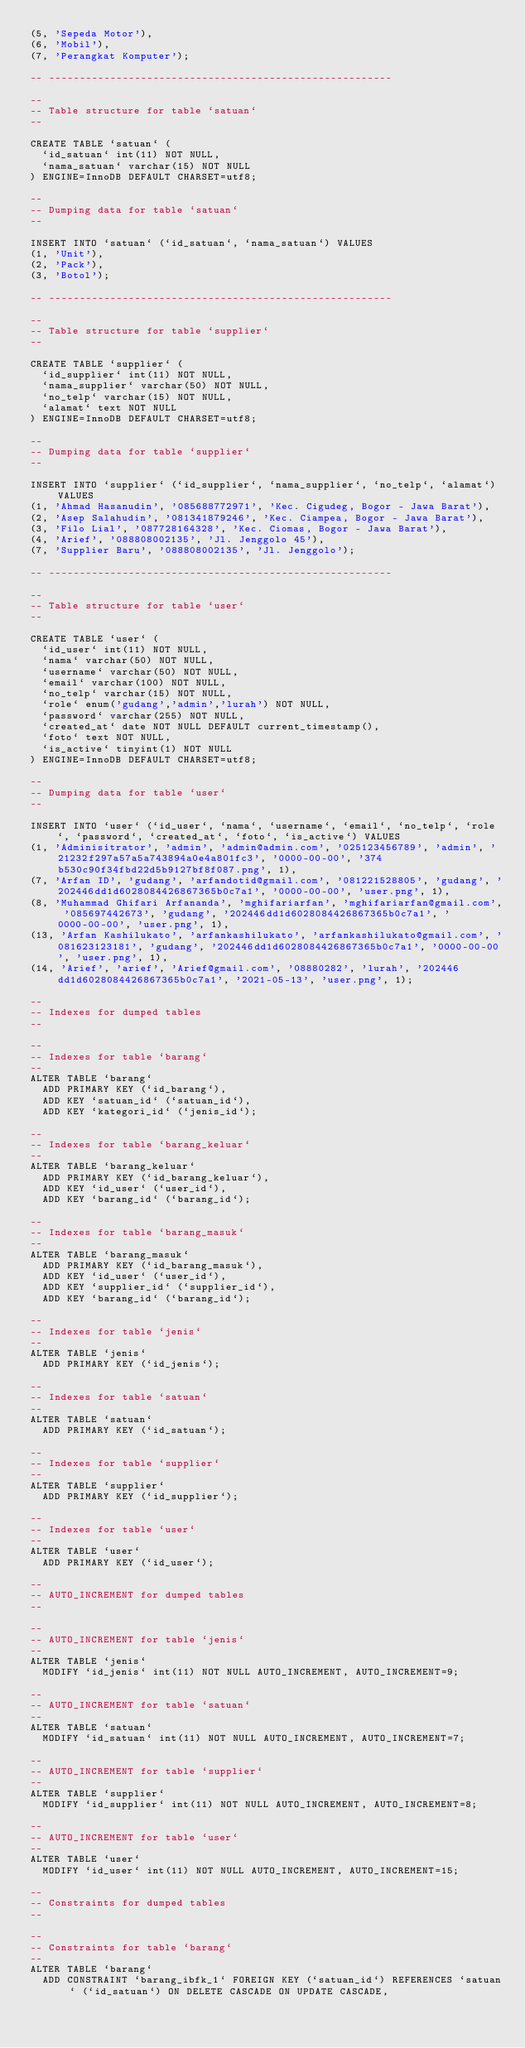Convert code to text. <code><loc_0><loc_0><loc_500><loc_500><_SQL_>(5, 'Sepeda Motor'),
(6, 'Mobil'),
(7, 'Perangkat Komputer');

-- --------------------------------------------------------

--
-- Table structure for table `satuan`
--

CREATE TABLE `satuan` (
  `id_satuan` int(11) NOT NULL,
  `nama_satuan` varchar(15) NOT NULL
) ENGINE=InnoDB DEFAULT CHARSET=utf8;

--
-- Dumping data for table `satuan`
--

INSERT INTO `satuan` (`id_satuan`, `nama_satuan`) VALUES
(1, 'Unit'),
(2, 'Pack'),
(3, 'Botol');

-- --------------------------------------------------------

--
-- Table structure for table `supplier`
--

CREATE TABLE `supplier` (
  `id_supplier` int(11) NOT NULL,
  `nama_supplier` varchar(50) NOT NULL,
  `no_telp` varchar(15) NOT NULL,
  `alamat` text NOT NULL
) ENGINE=InnoDB DEFAULT CHARSET=utf8;

--
-- Dumping data for table `supplier`
--

INSERT INTO `supplier` (`id_supplier`, `nama_supplier`, `no_telp`, `alamat`) VALUES
(1, 'Ahmad Hasanudin', '085688772971', 'Kec. Cigudeg, Bogor - Jawa Barat'),
(2, 'Asep Salahudin', '081341879246', 'Kec. Ciampea, Bogor - Jawa Barat'),
(3, 'Filo Lial', '087728164328', 'Kec. Ciomas, Bogor - Jawa Barat'),
(4, 'Arief', '088808002135', 'Jl. Jenggolo 45'),
(7, 'Supplier Baru', '088808002135', 'Jl. Jenggolo');

-- --------------------------------------------------------

--
-- Table structure for table `user`
--

CREATE TABLE `user` (
  `id_user` int(11) NOT NULL,
  `nama` varchar(50) NOT NULL,
  `username` varchar(50) NOT NULL,
  `email` varchar(100) NOT NULL,
  `no_telp` varchar(15) NOT NULL,
  `role` enum('gudang','admin','lurah') NOT NULL,
  `password` varchar(255) NOT NULL,
  `created_at` date NOT NULL DEFAULT current_timestamp(),
  `foto` text NOT NULL,
  `is_active` tinyint(1) NOT NULL
) ENGINE=InnoDB DEFAULT CHARSET=utf8;

--
-- Dumping data for table `user`
--

INSERT INTO `user` (`id_user`, `nama`, `username`, `email`, `no_telp`, `role`, `password`, `created_at`, `foto`, `is_active`) VALUES
(1, 'Adminisitrator', 'admin', 'admin@admin.com', '025123456789', 'admin', '21232f297a57a5a743894a0e4a801fc3', '0000-00-00', '374b530c90f34fbd22d5b9127bf8f087.png', 1),
(7, 'Arfan ID', 'gudang', 'arfandotid@gmail.com', '081221528805', 'gudang', '202446dd1d6028084426867365b0c7a1', '0000-00-00', 'user.png', 1),
(8, 'Muhammad Ghifari Arfananda', 'mghifariarfan', 'mghifariarfan@gmail.com', '085697442673', 'gudang', '202446dd1d6028084426867365b0c7a1', '0000-00-00', 'user.png', 1),
(13, 'Arfan Kashilukato', 'arfankashilukato', 'arfankashilukato@gmail.com', '081623123181', 'gudang', '202446dd1d6028084426867365b0c7a1', '0000-00-00', 'user.png', 1),
(14, 'Arief', 'arief', 'Arief@gmail.com', '08880282', 'lurah', '202446dd1d6028084426867365b0c7a1', '2021-05-13', 'user.png', 1);

--
-- Indexes for dumped tables
--

--
-- Indexes for table `barang`
--
ALTER TABLE `barang`
  ADD PRIMARY KEY (`id_barang`),
  ADD KEY `satuan_id` (`satuan_id`),
  ADD KEY `kategori_id` (`jenis_id`);

--
-- Indexes for table `barang_keluar`
--
ALTER TABLE `barang_keluar`
  ADD PRIMARY KEY (`id_barang_keluar`),
  ADD KEY `id_user` (`user_id`),
  ADD KEY `barang_id` (`barang_id`);

--
-- Indexes for table `barang_masuk`
--
ALTER TABLE `barang_masuk`
  ADD PRIMARY KEY (`id_barang_masuk`),
  ADD KEY `id_user` (`user_id`),
  ADD KEY `supplier_id` (`supplier_id`),
  ADD KEY `barang_id` (`barang_id`);

--
-- Indexes for table `jenis`
--
ALTER TABLE `jenis`
  ADD PRIMARY KEY (`id_jenis`);

--
-- Indexes for table `satuan`
--
ALTER TABLE `satuan`
  ADD PRIMARY KEY (`id_satuan`);

--
-- Indexes for table `supplier`
--
ALTER TABLE `supplier`
  ADD PRIMARY KEY (`id_supplier`);

--
-- Indexes for table `user`
--
ALTER TABLE `user`
  ADD PRIMARY KEY (`id_user`);

--
-- AUTO_INCREMENT for dumped tables
--

--
-- AUTO_INCREMENT for table `jenis`
--
ALTER TABLE `jenis`
  MODIFY `id_jenis` int(11) NOT NULL AUTO_INCREMENT, AUTO_INCREMENT=9;

--
-- AUTO_INCREMENT for table `satuan`
--
ALTER TABLE `satuan`
  MODIFY `id_satuan` int(11) NOT NULL AUTO_INCREMENT, AUTO_INCREMENT=7;

--
-- AUTO_INCREMENT for table `supplier`
--
ALTER TABLE `supplier`
  MODIFY `id_supplier` int(11) NOT NULL AUTO_INCREMENT, AUTO_INCREMENT=8;

--
-- AUTO_INCREMENT for table `user`
--
ALTER TABLE `user`
  MODIFY `id_user` int(11) NOT NULL AUTO_INCREMENT, AUTO_INCREMENT=15;

--
-- Constraints for dumped tables
--

--
-- Constraints for table `barang`
--
ALTER TABLE `barang`
  ADD CONSTRAINT `barang_ibfk_1` FOREIGN KEY (`satuan_id`) REFERENCES `satuan` (`id_satuan`) ON DELETE CASCADE ON UPDATE CASCADE,</code> 